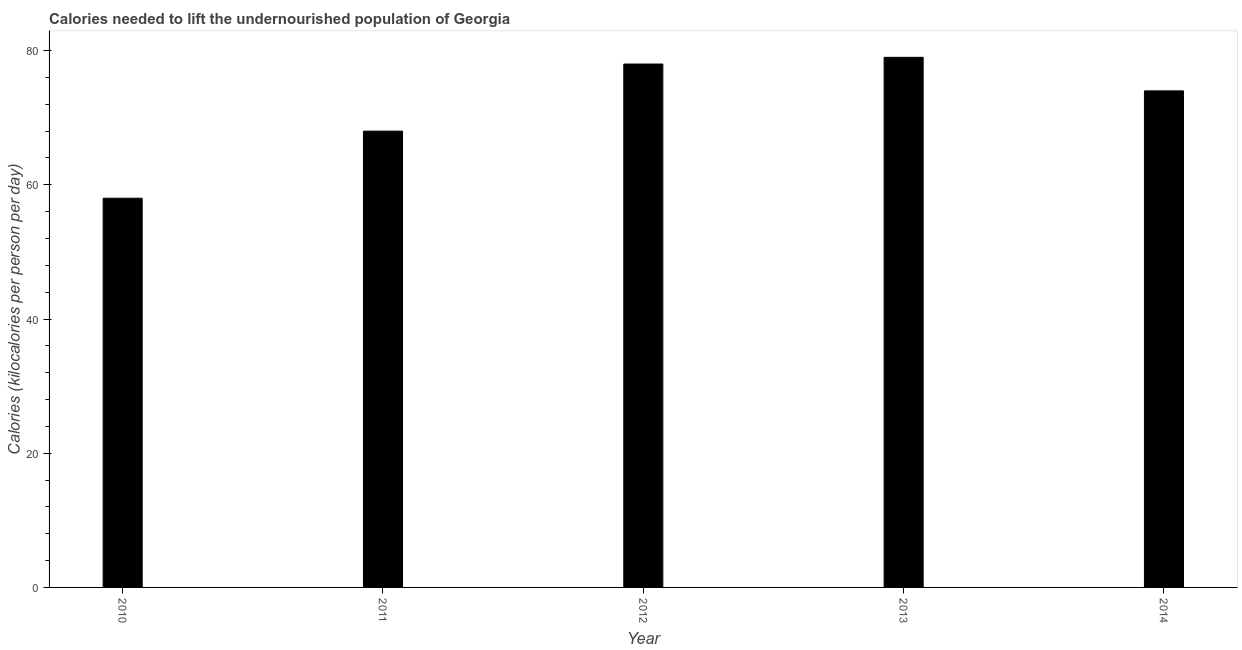Does the graph contain any zero values?
Your answer should be compact. No. What is the title of the graph?
Ensure brevity in your answer.  Calories needed to lift the undernourished population of Georgia. What is the label or title of the X-axis?
Provide a succinct answer. Year. What is the label or title of the Y-axis?
Offer a terse response. Calories (kilocalories per person per day). What is the depth of food deficit in 2012?
Offer a very short reply. 78. Across all years, what is the maximum depth of food deficit?
Make the answer very short. 79. Across all years, what is the minimum depth of food deficit?
Offer a very short reply. 58. What is the sum of the depth of food deficit?
Your response must be concise. 357. Do a majority of the years between 2010 and 2012 (inclusive) have depth of food deficit greater than 72 kilocalories?
Make the answer very short. No. What is the ratio of the depth of food deficit in 2011 to that in 2013?
Ensure brevity in your answer.  0.86. Is the depth of food deficit in 2012 less than that in 2013?
Keep it short and to the point. Yes. Is the difference between the depth of food deficit in 2013 and 2014 greater than the difference between any two years?
Make the answer very short. No. What is the difference between the highest and the second highest depth of food deficit?
Your answer should be compact. 1. What is the Calories (kilocalories per person per day) of 2010?
Ensure brevity in your answer.  58. What is the Calories (kilocalories per person per day) in 2013?
Provide a succinct answer. 79. What is the difference between the Calories (kilocalories per person per day) in 2010 and 2012?
Provide a short and direct response. -20. What is the difference between the Calories (kilocalories per person per day) in 2010 and 2013?
Keep it short and to the point. -21. What is the difference between the Calories (kilocalories per person per day) in 2010 and 2014?
Ensure brevity in your answer.  -16. What is the difference between the Calories (kilocalories per person per day) in 2011 and 2012?
Your answer should be very brief. -10. What is the difference between the Calories (kilocalories per person per day) in 2011 and 2013?
Provide a succinct answer. -11. What is the difference between the Calories (kilocalories per person per day) in 2012 and 2014?
Your answer should be very brief. 4. What is the ratio of the Calories (kilocalories per person per day) in 2010 to that in 2011?
Offer a very short reply. 0.85. What is the ratio of the Calories (kilocalories per person per day) in 2010 to that in 2012?
Provide a short and direct response. 0.74. What is the ratio of the Calories (kilocalories per person per day) in 2010 to that in 2013?
Offer a very short reply. 0.73. What is the ratio of the Calories (kilocalories per person per day) in 2010 to that in 2014?
Provide a succinct answer. 0.78. What is the ratio of the Calories (kilocalories per person per day) in 2011 to that in 2012?
Ensure brevity in your answer.  0.87. What is the ratio of the Calories (kilocalories per person per day) in 2011 to that in 2013?
Give a very brief answer. 0.86. What is the ratio of the Calories (kilocalories per person per day) in 2011 to that in 2014?
Provide a short and direct response. 0.92. What is the ratio of the Calories (kilocalories per person per day) in 2012 to that in 2013?
Give a very brief answer. 0.99. What is the ratio of the Calories (kilocalories per person per day) in 2012 to that in 2014?
Give a very brief answer. 1.05. What is the ratio of the Calories (kilocalories per person per day) in 2013 to that in 2014?
Keep it short and to the point. 1.07. 